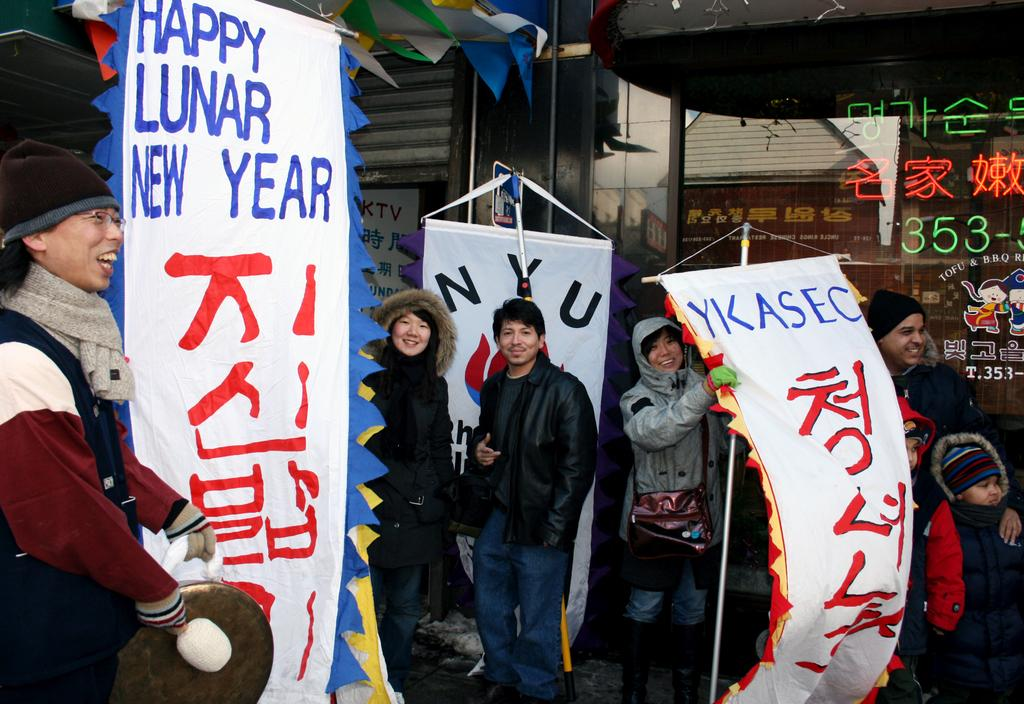How many people are in the image? There is a group of people in the image, but the exact number cannot be determined from the provided facts. What can be seen hanging in the image? There are banners in the image. What type of objects can be seen in the image besides people and banners? There are decorative objects and some other objects in the image. Can you tell me how many pigs are visible in the image? There are no pigs present in the image. What type of vegetable is being used as a decorative object in the image? There is no vegetable used as a decorative object in the image. 